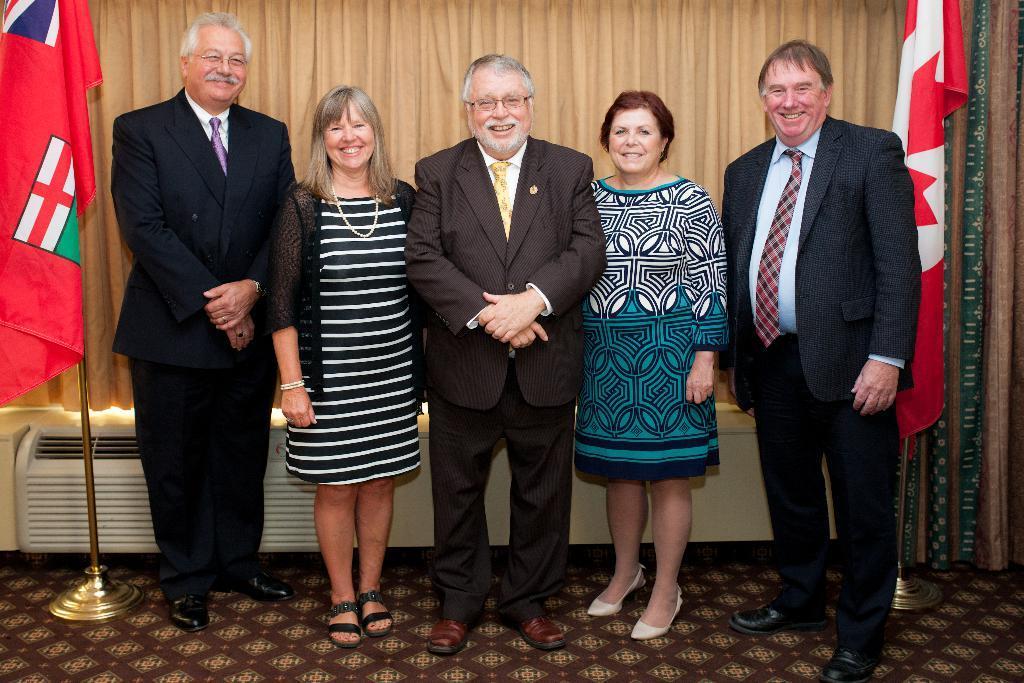Please provide a concise description of this image. In this image we can see a group of five standing people. There is a curtain in the image. There are two flags in the image. There is an object behind a group of people. 